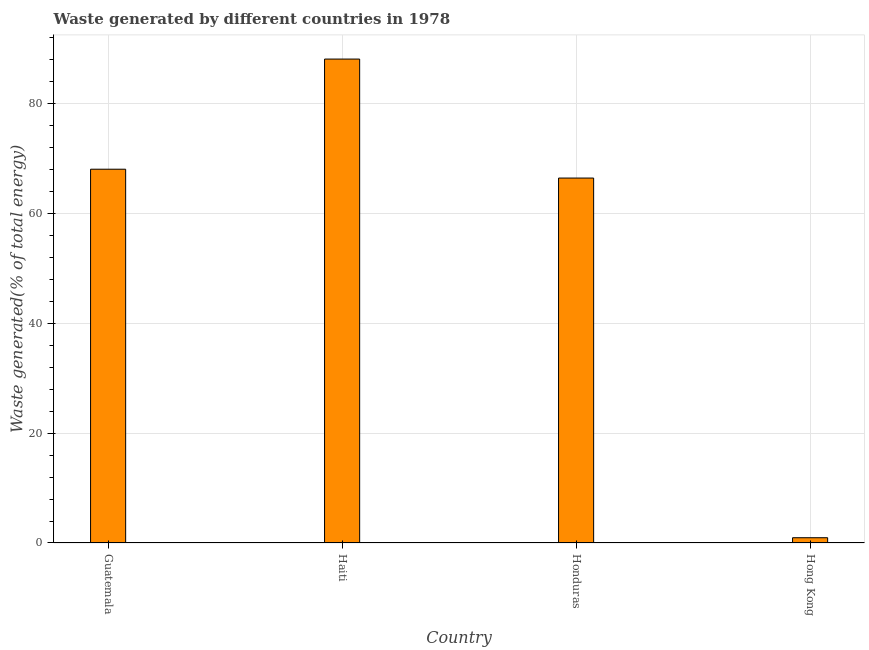Does the graph contain grids?
Give a very brief answer. Yes. What is the title of the graph?
Your response must be concise. Waste generated by different countries in 1978. What is the label or title of the X-axis?
Give a very brief answer. Country. What is the label or title of the Y-axis?
Make the answer very short. Waste generated(% of total energy). What is the amount of waste generated in Honduras?
Give a very brief answer. 66.42. Across all countries, what is the maximum amount of waste generated?
Keep it short and to the point. 88.07. Across all countries, what is the minimum amount of waste generated?
Your answer should be very brief. 0.96. In which country was the amount of waste generated maximum?
Provide a succinct answer. Haiti. In which country was the amount of waste generated minimum?
Keep it short and to the point. Hong Kong. What is the sum of the amount of waste generated?
Your response must be concise. 223.47. What is the difference between the amount of waste generated in Guatemala and Hong Kong?
Your response must be concise. 67.07. What is the average amount of waste generated per country?
Ensure brevity in your answer.  55.87. What is the median amount of waste generated?
Give a very brief answer. 67.22. In how many countries, is the amount of waste generated greater than 44 %?
Provide a succinct answer. 3. What is the ratio of the amount of waste generated in Guatemala to that in Honduras?
Ensure brevity in your answer.  1.02. Is the difference between the amount of waste generated in Guatemala and Honduras greater than the difference between any two countries?
Keep it short and to the point. No. What is the difference between the highest and the second highest amount of waste generated?
Your answer should be compact. 20.04. Is the sum of the amount of waste generated in Honduras and Hong Kong greater than the maximum amount of waste generated across all countries?
Your answer should be compact. No. What is the difference between the highest and the lowest amount of waste generated?
Your answer should be compact. 87.11. In how many countries, is the amount of waste generated greater than the average amount of waste generated taken over all countries?
Provide a short and direct response. 3. How many countries are there in the graph?
Give a very brief answer. 4. What is the difference between two consecutive major ticks on the Y-axis?
Provide a succinct answer. 20. What is the Waste generated(% of total energy) of Guatemala?
Make the answer very short. 68.03. What is the Waste generated(% of total energy) in Haiti?
Make the answer very short. 88.07. What is the Waste generated(% of total energy) of Honduras?
Your answer should be compact. 66.42. What is the Waste generated(% of total energy) of Hong Kong?
Make the answer very short. 0.96. What is the difference between the Waste generated(% of total energy) in Guatemala and Haiti?
Ensure brevity in your answer.  -20.04. What is the difference between the Waste generated(% of total energy) in Guatemala and Honduras?
Offer a terse response. 1.61. What is the difference between the Waste generated(% of total energy) in Guatemala and Hong Kong?
Provide a short and direct response. 67.07. What is the difference between the Waste generated(% of total energy) in Haiti and Honduras?
Provide a succinct answer. 21.65. What is the difference between the Waste generated(% of total energy) in Haiti and Hong Kong?
Your answer should be compact. 87.11. What is the difference between the Waste generated(% of total energy) in Honduras and Hong Kong?
Your response must be concise. 65.46. What is the ratio of the Waste generated(% of total energy) in Guatemala to that in Haiti?
Offer a very short reply. 0.77. What is the ratio of the Waste generated(% of total energy) in Guatemala to that in Honduras?
Provide a succinct answer. 1.02. What is the ratio of the Waste generated(% of total energy) in Guatemala to that in Hong Kong?
Your answer should be very brief. 71.06. What is the ratio of the Waste generated(% of total energy) in Haiti to that in Honduras?
Offer a terse response. 1.33. What is the ratio of the Waste generated(% of total energy) in Haiti to that in Hong Kong?
Your answer should be very brief. 91.99. What is the ratio of the Waste generated(% of total energy) in Honduras to that in Hong Kong?
Ensure brevity in your answer.  69.38. 